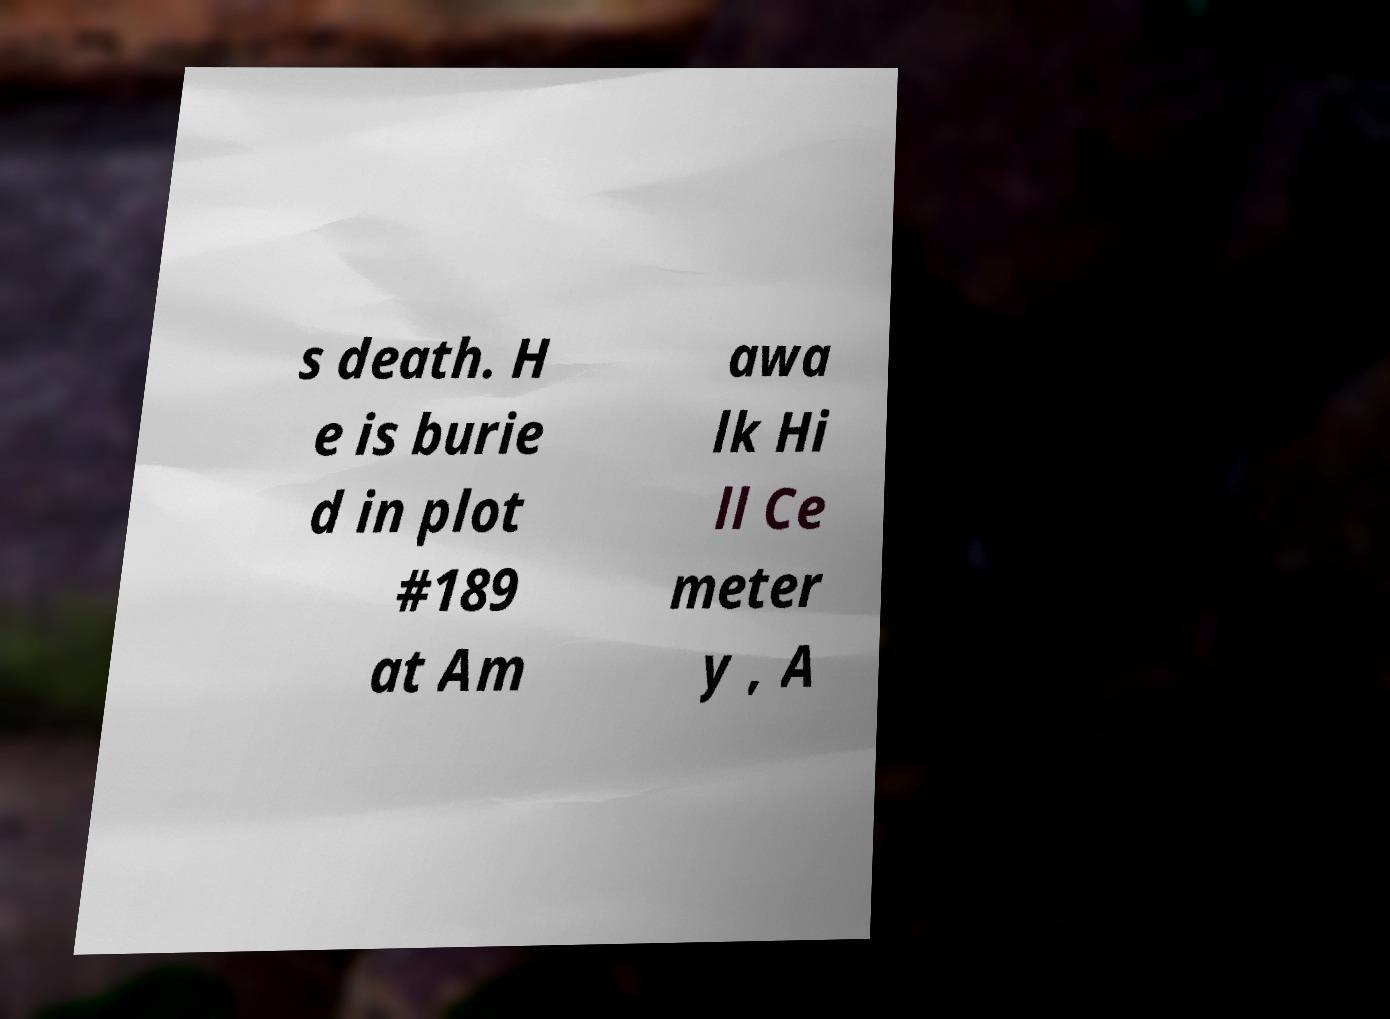Could you extract and type out the text from this image? s death. H e is burie d in plot #189 at Am awa lk Hi ll Ce meter y , A 